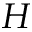<formula> <loc_0><loc_0><loc_500><loc_500>H</formula> 